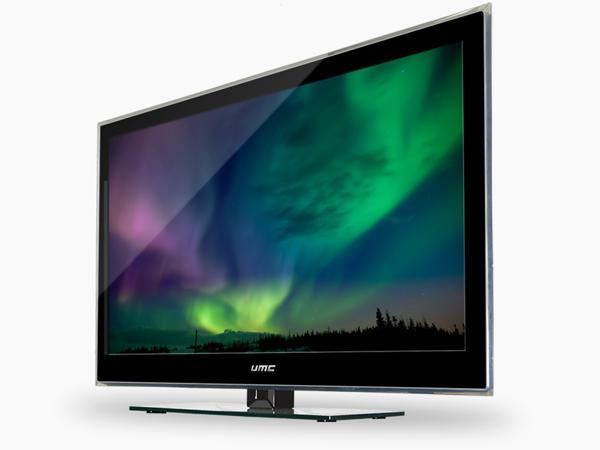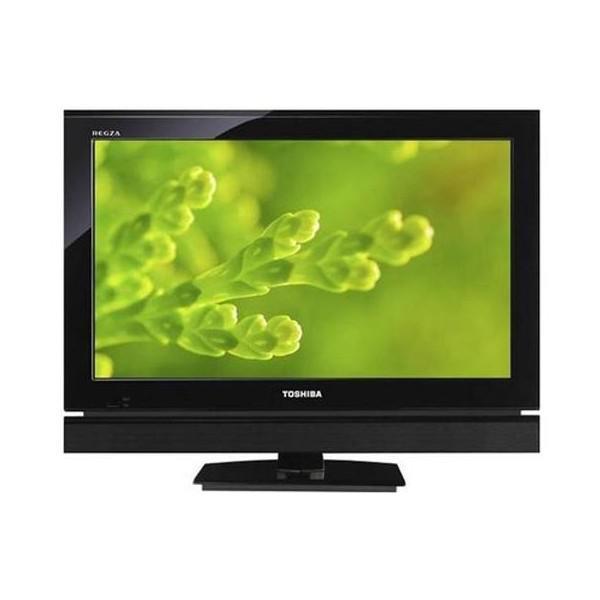The first image is the image on the left, the second image is the image on the right. Examine the images to the left and right. Is the description "The TV on the right is viewed head-on, and the TV on the left is displayed at an angle." accurate? Answer yes or no. Yes. 